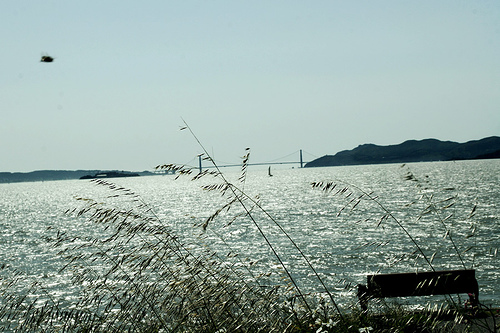<image>What year was this photo taken? It is unclear what year the photo was taken. What year was this photo taken? I don't know the year when this photo was taken. It can be 1978, 2014, 2016, 2012, 2000, 1989, or 1950. 